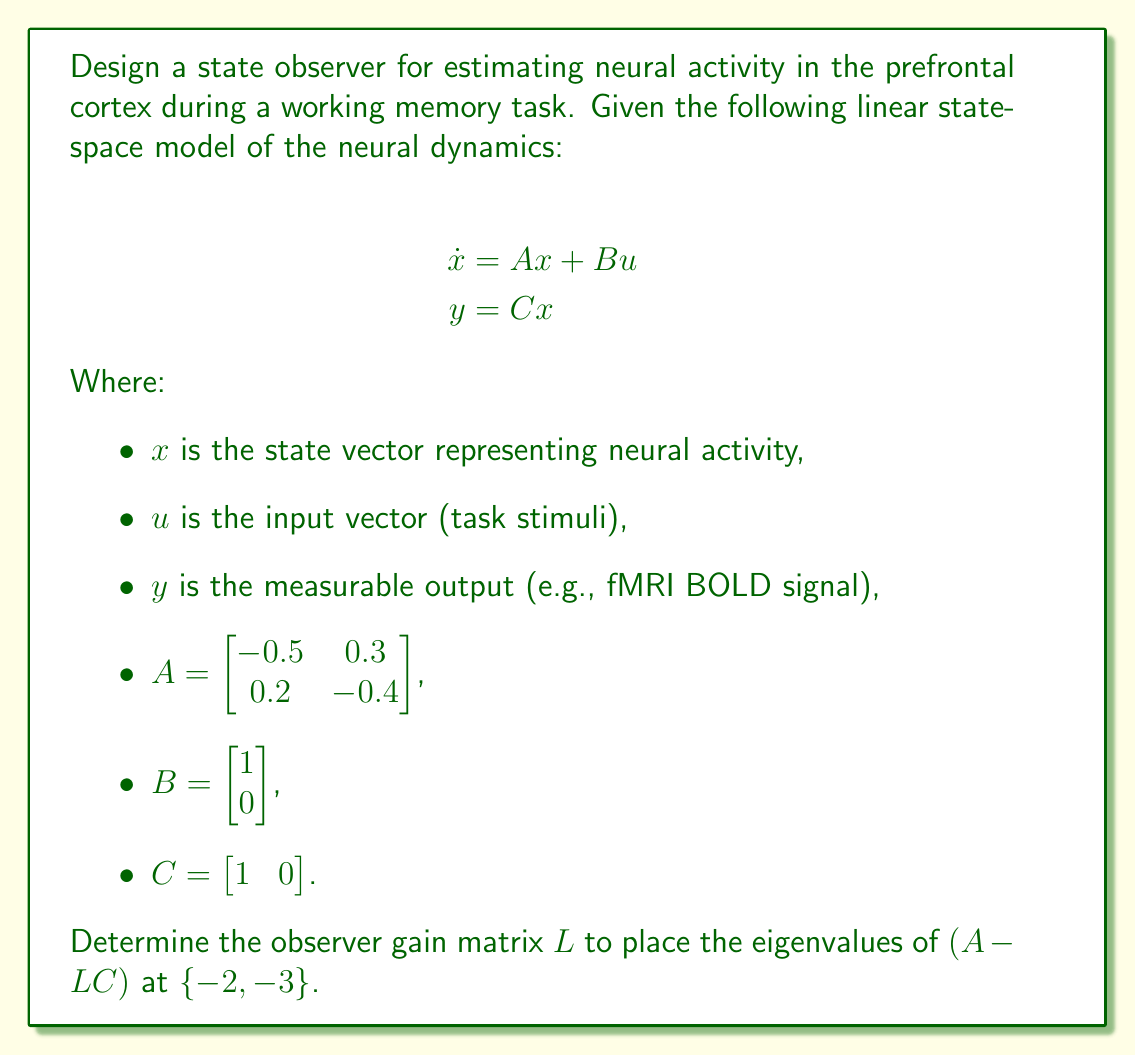Give your solution to this math problem. To design a state observer for estimating neural activity, we need to determine the observer gain matrix $L$ that will place the eigenvalues of $(A - LC)$ at the desired locations. This process is known as pole placement.

Given:
$A = \begin{bmatrix} -0.5 & 0.3 \\ 0.2 & -0.4 \end{bmatrix}$
$C = \begin{bmatrix} 1 & 0 \end{bmatrix}$
Desired eigenvalues: $\{-2, -3\}$

Step 1: Determine the characteristic equation of $(A - LC)$.
Let $L = \begin{bmatrix} l_1 \\ l_2 \end{bmatrix}$

$A - LC = \begin{bmatrix} -0.5 - l_1 & 0.3 \\ 0.2 - l_2 & -0.4 \end{bmatrix}$

The characteristic equation is:
$\det(sI - (A - LC)) = s^2 + (0.9 + l_1)s + (0.13 + 0.4l_1 + 0.3l_2)$

Step 2: Set up the desired characteristic equation based on the given eigenvalues.
$(s + 2)(s + 3) = s^2 + 5s + 6$

Step 3: Equate the coefficients of the two characteristic equations.
$0.9 + l_1 = 5$
$0.13 + 0.4l_1 + 0.3l_2 = 6$

Step 4: Solve the system of equations.
From the first equation:
$l_1 = 5 - 0.9 = 4.1$

Substituting this into the second equation:
$0.13 + 0.4(4.1) + 0.3l_2 = 6$
$1.77 + 0.3l_2 = 6$
$0.3l_2 = 4.23$
$l_2 = 14.1$

Therefore, the observer gain matrix $L$ is:
$L = \begin{bmatrix} 4.1 \\ 14.1 \end{bmatrix}$

Step 5: Verify the eigenvalues of $(A - LC)$.
$A - LC = \begin{bmatrix} -4.6 & 0.3 \\ -13.9 & -0.4 \end{bmatrix}$

The eigenvalues of this matrix can be calculated to confirm they are indeed $\{-2, -3\}$.
Answer: $L = \begin{bmatrix} 4.1 \\ 14.1 \end{bmatrix}$ 